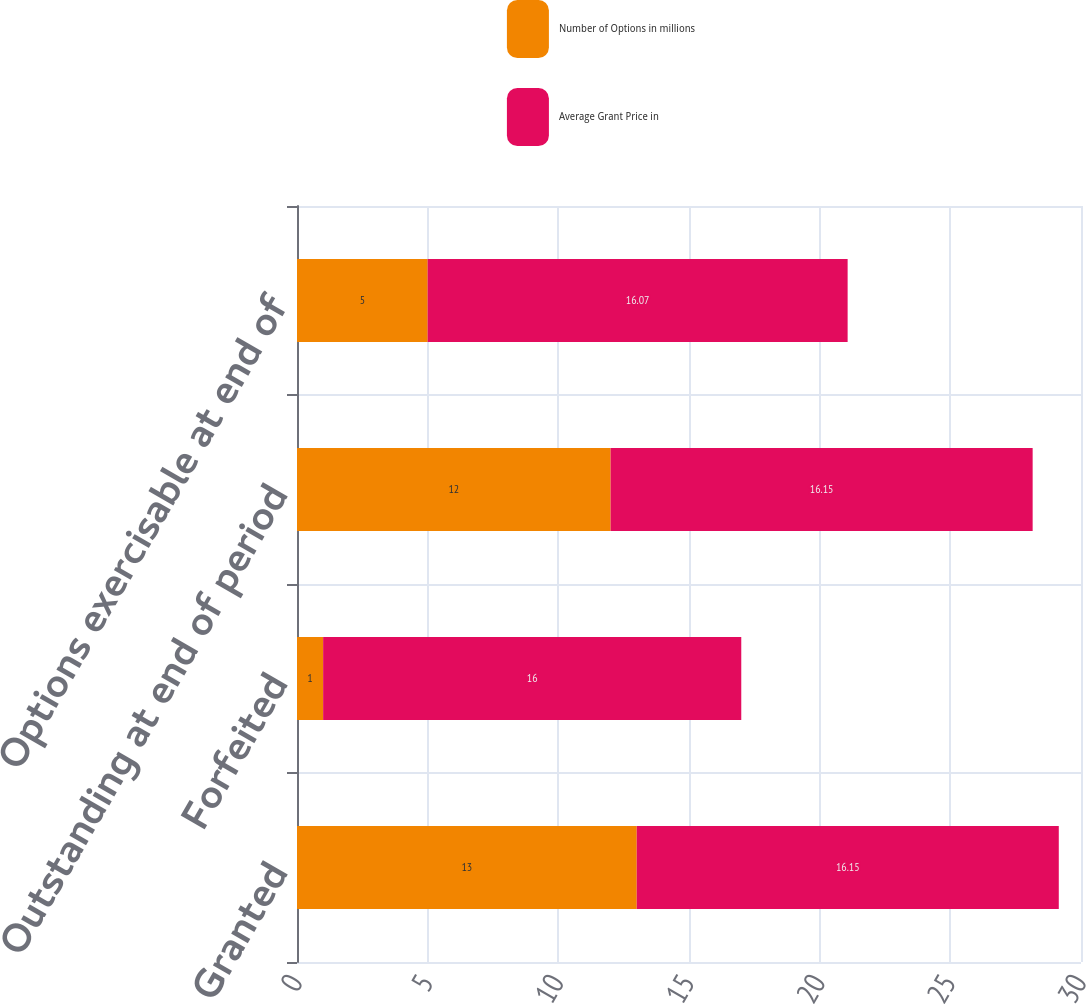Convert chart. <chart><loc_0><loc_0><loc_500><loc_500><stacked_bar_chart><ecel><fcel>Granted<fcel>Forfeited<fcel>Outstanding at end of period<fcel>Options exercisable at end of<nl><fcel>Number of Options in millions<fcel>13<fcel>1<fcel>12<fcel>5<nl><fcel>Average Grant Price in<fcel>16.15<fcel>16<fcel>16.15<fcel>16.07<nl></chart> 